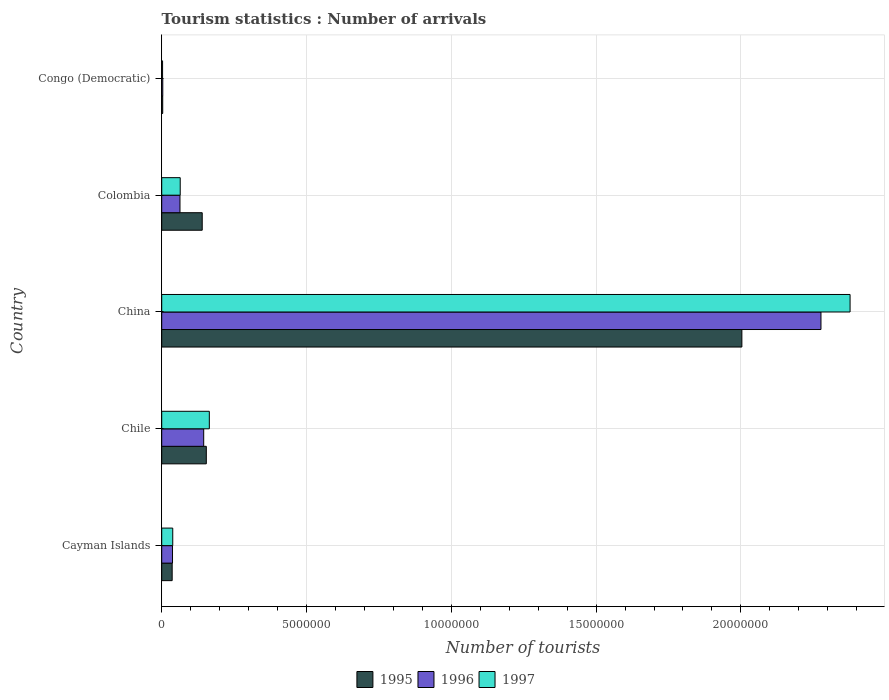How many different coloured bars are there?
Keep it short and to the point. 3. How many groups of bars are there?
Your response must be concise. 5. Are the number of bars per tick equal to the number of legend labels?
Ensure brevity in your answer.  Yes. Are the number of bars on each tick of the Y-axis equal?
Offer a terse response. Yes. How many bars are there on the 1st tick from the bottom?
Offer a terse response. 3. What is the label of the 1st group of bars from the top?
Your response must be concise. Congo (Democratic). In how many cases, is the number of bars for a given country not equal to the number of legend labels?
Keep it short and to the point. 0. What is the number of tourist arrivals in 1997 in Colombia?
Your answer should be very brief. 6.39e+05. Across all countries, what is the maximum number of tourist arrivals in 1997?
Your answer should be very brief. 2.38e+07. Across all countries, what is the minimum number of tourist arrivals in 1997?
Provide a short and direct response. 3.00e+04. In which country was the number of tourist arrivals in 1996 minimum?
Provide a short and direct response. Congo (Democratic). What is the total number of tourist arrivals in 1996 in the graph?
Offer a terse response. 2.53e+07. What is the difference between the number of tourist arrivals in 1996 in Chile and that in China?
Provide a succinct answer. -2.13e+07. What is the difference between the number of tourist arrivals in 1997 in Chile and the number of tourist arrivals in 1996 in Congo (Democratic)?
Your response must be concise. 1.61e+06. What is the average number of tourist arrivals in 1997 per country?
Offer a terse response. 5.29e+06. What is the difference between the number of tourist arrivals in 1996 and number of tourist arrivals in 1995 in China?
Offer a very short reply. 2.73e+06. What is the ratio of the number of tourist arrivals in 1996 in Chile to that in Colombia?
Offer a very short reply. 2.3. Is the number of tourist arrivals in 1997 in Cayman Islands less than that in China?
Provide a succinct answer. Yes. Is the difference between the number of tourist arrivals in 1996 in Chile and Congo (Democratic) greater than the difference between the number of tourist arrivals in 1995 in Chile and Congo (Democratic)?
Ensure brevity in your answer.  No. What is the difference between the highest and the second highest number of tourist arrivals in 1996?
Your response must be concise. 2.13e+07. What is the difference between the highest and the lowest number of tourist arrivals in 1995?
Keep it short and to the point. 2.00e+07. In how many countries, is the number of tourist arrivals in 1996 greater than the average number of tourist arrivals in 1996 taken over all countries?
Provide a short and direct response. 1. What does the 1st bar from the top in Colombia represents?
Give a very brief answer. 1997. What does the 2nd bar from the bottom in Colombia represents?
Keep it short and to the point. 1996. Is it the case that in every country, the sum of the number of tourist arrivals in 1995 and number of tourist arrivals in 1997 is greater than the number of tourist arrivals in 1996?
Keep it short and to the point. Yes. What is the difference between two consecutive major ticks on the X-axis?
Provide a succinct answer. 5.00e+06. Are the values on the major ticks of X-axis written in scientific E-notation?
Make the answer very short. No. How many legend labels are there?
Offer a terse response. 3. What is the title of the graph?
Provide a short and direct response. Tourism statistics : Number of arrivals. Does "1971" appear as one of the legend labels in the graph?
Make the answer very short. No. What is the label or title of the X-axis?
Make the answer very short. Number of tourists. What is the label or title of the Y-axis?
Your answer should be compact. Country. What is the Number of tourists of 1995 in Cayman Islands?
Offer a terse response. 3.61e+05. What is the Number of tourists in 1996 in Cayman Islands?
Ensure brevity in your answer.  3.73e+05. What is the Number of tourists in 1997 in Cayman Islands?
Your answer should be very brief. 3.81e+05. What is the Number of tourists in 1995 in Chile?
Your answer should be compact. 1.54e+06. What is the Number of tourists in 1996 in Chile?
Offer a very short reply. 1.45e+06. What is the Number of tourists in 1997 in Chile?
Your answer should be very brief. 1.64e+06. What is the Number of tourists of 1995 in China?
Make the answer very short. 2.00e+07. What is the Number of tourists in 1996 in China?
Your response must be concise. 2.28e+07. What is the Number of tourists of 1997 in China?
Offer a very short reply. 2.38e+07. What is the Number of tourists of 1995 in Colombia?
Your answer should be compact. 1.40e+06. What is the Number of tourists in 1996 in Colombia?
Keep it short and to the point. 6.31e+05. What is the Number of tourists in 1997 in Colombia?
Keep it short and to the point. 6.39e+05. What is the Number of tourists of 1995 in Congo (Democratic)?
Give a very brief answer. 3.50e+04. What is the Number of tourists in 1996 in Congo (Democratic)?
Provide a succinct answer. 3.70e+04. Across all countries, what is the maximum Number of tourists in 1995?
Offer a terse response. 2.00e+07. Across all countries, what is the maximum Number of tourists in 1996?
Offer a very short reply. 2.28e+07. Across all countries, what is the maximum Number of tourists of 1997?
Offer a terse response. 2.38e+07. Across all countries, what is the minimum Number of tourists of 1995?
Your answer should be very brief. 3.50e+04. Across all countries, what is the minimum Number of tourists in 1996?
Offer a terse response. 3.70e+04. Across all countries, what is the minimum Number of tourists in 1997?
Keep it short and to the point. 3.00e+04. What is the total Number of tourists of 1995 in the graph?
Your answer should be very brief. 2.34e+07. What is the total Number of tourists of 1996 in the graph?
Give a very brief answer. 2.53e+07. What is the total Number of tourists of 1997 in the graph?
Make the answer very short. 2.65e+07. What is the difference between the Number of tourists in 1995 in Cayman Islands and that in Chile?
Keep it short and to the point. -1.18e+06. What is the difference between the Number of tourists of 1996 in Cayman Islands and that in Chile?
Your response must be concise. -1.08e+06. What is the difference between the Number of tourists in 1997 in Cayman Islands and that in Chile?
Your answer should be compact. -1.26e+06. What is the difference between the Number of tourists of 1995 in Cayman Islands and that in China?
Provide a short and direct response. -1.97e+07. What is the difference between the Number of tourists of 1996 in Cayman Islands and that in China?
Provide a succinct answer. -2.24e+07. What is the difference between the Number of tourists of 1997 in Cayman Islands and that in China?
Ensure brevity in your answer.  -2.34e+07. What is the difference between the Number of tourists in 1995 in Cayman Islands and that in Colombia?
Offer a terse response. -1.04e+06. What is the difference between the Number of tourists of 1996 in Cayman Islands and that in Colombia?
Offer a very short reply. -2.58e+05. What is the difference between the Number of tourists in 1997 in Cayman Islands and that in Colombia?
Offer a very short reply. -2.58e+05. What is the difference between the Number of tourists of 1995 in Cayman Islands and that in Congo (Democratic)?
Your response must be concise. 3.26e+05. What is the difference between the Number of tourists in 1996 in Cayman Islands and that in Congo (Democratic)?
Your response must be concise. 3.36e+05. What is the difference between the Number of tourists in 1997 in Cayman Islands and that in Congo (Democratic)?
Your answer should be compact. 3.51e+05. What is the difference between the Number of tourists of 1995 in Chile and that in China?
Ensure brevity in your answer.  -1.85e+07. What is the difference between the Number of tourists of 1996 in Chile and that in China?
Keep it short and to the point. -2.13e+07. What is the difference between the Number of tourists of 1997 in Chile and that in China?
Provide a succinct answer. -2.21e+07. What is the difference between the Number of tourists of 1995 in Chile and that in Colombia?
Ensure brevity in your answer.  1.41e+05. What is the difference between the Number of tourists of 1996 in Chile and that in Colombia?
Provide a short and direct response. 8.19e+05. What is the difference between the Number of tourists in 1997 in Chile and that in Colombia?
Your response must be concise. 1.00e+06. What is the difference between the Number of tourists in 1995 in Chile and that in Congo (Democratic)?
Provide a short and direct response. 1.50e+06. What is the difference between the Number of tourists in 1996 in Chile and that in Congo (Democratic)?
Make the answer very short. 1.41e+06. What is the difference between the Number of tourists of 1997 in Chile and that in Congo (Democratic)?
Your answer should be very brief. 1.61e+06. What is the difference between the Number of tourists of 1995 in China and that in Colombia?
Give a very brief answer. 1.86e+07. What is the difference between the Number of tourists in 1996 in China and that in Colombia?
Give a very brief answer. 2.21e+07. What is the difference between the Number of tourists in 1997 in China and that in Colombia?
Give a very brief answer. 2.31e+07. What is the difference between the Number of tourists in 1995 in China and that in Congo (Democratic)?
Your answer should be very brief. 2.00e+07. What is the difference between the Number of tourists in 1996 in China and that in Congo (Democratic)?
Keep it short and to the point. 2.27e+07. What is the difference between the Number of tourists of 1997 in China and that in Congo (Democratic)?
Your answer should be compact. 2.37e+07. What is the difference between the Number of tourists of 1995 in Colombia and that in Congo (Democratic)?
Provide a succinct answer. 1.36e+06. What is the difference between the Number of tourists in 1996 in Colombia and that in Congo (Democratic)?
Offer a very short reply. 5.94e+05. What is the difference between the Number of tourists in 1997 in Colombia and that in Congo (Democratic)?
Your answer should be very brief. 6.09e+05. What is the difference between the Number of tourists in 1995 in Cayman Islands and the Number of tourists in 1996 in Chile?
Make the answer very short. -1.09e+06. What is the difference between the Number of tourists in 1995 in Cayman Islands and the Number of tourists in 1997 in Chile?
Offer a terse response. -1.28e+06. What is the difference between the Number of tourists of 1996 in Cayman Islands and the Number of tourists of 1997 in Chile?
Your answer should be compact. -1.27e+06. What is the difference between the Number of tourists of 1995 in Cayman Islands and the Number of tourists of 1996 in China?
Ensure brevity in your answer.  -2.24e+07. What is the difference between the Number of tourists in 1995 in Cayman Islands and the Number of tourists in 1997 in China?
Offer a very short reply. -2.34e+07. What is the difference between the Number of tourists in 1996 in Cayman Islands and the Number of tourists in 1997 in China?
Keep it short and to the point. -2.34e+07. What is the difference between the Number of tourists of 1995 in Cayman Islands and the Number of tourists of 1996 in Colombia?
Offer a very short reply. -2.70e+05. What is the difference between the Number of tourists in 1995 in Cayman Islands and the Number of tourists in 1997 in Colombia?
Keep it short and to the point. -2.78e+05. What is the difference between the Number of tourists in 1996 in Cayman Islands and the Number of tourists in 1997 in Colombia?
Ensure brevity in your answer.  -2.66e+05. What is the difference between the Number of tourists in 1995 in Cayman Islands and the Number of tourists in 1996 in Congo (Democratic)?
Make the answer very short. 3.24e+05. What is the difference between the Number of tourists of 1995 in Cayman Islands and the Number of tourists of 1997 in Congo (Democratic)?
Offer a terse response. 3.31e+05. What is the difference between the Number of tourists of 1996 in Cayman Islands and the Number of tourists of 1997 in Congo (Democratic)?
Keep it short and to the point. 3.43e+05. What is the difference between the Number of tourists of 1995 in Chile and the Number of tourists of 1996 in China?
Give a very brief answer. -2.12e+07. What is the difference between the Number of tourists of 1995 in Chile and the Number of tourists of 1997 in China?
Make the answer very short. -2.22e+07. What is the difference between the Number of tourists of 1996 in Chile and the Number of tourists of 1997 in China?
Keep it short and to the point. -2.23e+07. What is the difference between the Number of tourists of 1995 in Chile and the Number of tourists of 1996 in Colombia?
Your answer should be very brief. 9.09e+05. What is the difference between the Number of tourists in 1995 in Chile and the Number of tourists in 1997 in Colombia?
Give a very brief answer. 9.01e+05. What is the difference between the Number of tourists in 1996 in Chile and the Number of tourists in 1997 in Colombia?
Keep it short and to the point. 8.11e+05. What is the difference between the Number of tourists in 1995 in Chile and the Number of tourists in 1996 in Congo (Democratic)?
Provide a short and direct response. 1.50e+06. What is the difference between the Number of tourists of 1995 in Chile and the Number of tourists of 1997 in Congo (Democratic)?
Offer a very short reply. 1.51e+06. What is the difference between the Number of tourists of 1996 in Chile and the Number of tourists of 1997 in Congo (Democratic)?
Keep it short and to the point. 1.42e+06. What is the difference between the Number of tourists of 1995 in China and the Number of tourists of 1996 in Colombia?
Your answer should be very brief. 1.94e+07. What is the difference between the Number of tourists of 1995 in China and the Number of tourists of 1997 in Colombia?
Give a very brief answer. 1.94e+07. What is the difference between the Number of tourists of 1996 in China and the Number of tourists of 1997 in Colombia?
Your answer should be very brief. 2.21e+07. What is the difference between the Number of tourists of 1995 in China and the Number of tourists of 1996 in Congo (Democratic)?
Your answer should be very brief. 2.00e+07. What is the difference between the Number of tourists of 1995 in China and the Number of tourists of 1997 in Congo (Democratic)?
Your answer should be very brief. 2.00e+07. What is the difference between the Number of tourists in 1996 in China and the Number of tourists in 1997 in Congo (Democratic)?
Your answer should be very brief. 2.27e+07. What is the difference between the Number of tourists in 1995 in Colombia and the Number of tourists in 1996 in Congo (Democratic)?
Offer a very short reply. 1.36e+06. What is the difference between the Number of tourists in 1995 in Colombia and the Number of tourists in 1997 in Congo (Democratic)?
Your answer should be very brief. 1.37e+06. What is the difference between the Number of tourists of 1996 in Colombia and the Number of tourists of 1997 in Congo (Democratic)?
Offer a terse response. 6.01e+05. What is the average Number of tourists of 1995 per country?
Provide a succinct answer. 4.67e+06. What is the average Number of tourists in 1996 per country?
Provide a short and direct response. 5.05e+06. What is the average Number of tourists in 1997 per country?
Your response must be concise. 5.29e+06. What is the difference between the Number of tourists in 1995 and Number of tourists in 1996 in Cayman Islands?
Make the answer very short. -1.20e+04. What is the difference between the Number of tourists of 1996 and Number of tourists of 1997 in Cayman Islands?
Offer a very short reply. -8000. What is the difference between the Number of tourists of 1995 and Number of tourists of 1996 in Chile?
Offer a very short reply. 9.00e+04. What is the difference between the Number of tourists of 1995 and Number of tourists of 1997 in Chile?
Make the answer very short. -1.04e+05. What is the difference between the Number of tourists of 1996 and Number of tourists of 1997 in Chile?
Your answer should be very brief. -1.94e+05. What is the difference between the Number of tourists in 1995 and Number of tourists in 1996 in China?
Your answer should be compact. -2.73e+06. What is the difference between the Number of tourists of 1995 and Number of tourists of 1997 in China?
Give a very brief answer. -3.74e+06. What is the difference between the Number of tourists in 1996 and Number of tourists in 1997 in China?
Offer a terse response. -1.00e+06. What is the difference between the Number of tourists in 1995 and Number of tourists in 1996 in Colombia?
Keep it short and to the point. 7.68e+05. What is the difference between the Number of tourists of 1995 and Number of tourists of 1997 in Colombia?
Offer a terse response. 7.60e+05. What is the difference between the Number of tourists of 1996 and Number of tourists of 1997 in Colombia?
Your response must be concise. -8000. What is the difference between the Number of tourists in 1995 and Number of tourists in 1996 in Congo (Democratic)?
Your answer should be very brief. -2000. What is the difference between the Number of tourists in 1995 and Number of tourists in 1997 in Congo (Democratic)?
Keep it short and to the point. 5000. What is the difference between the Number of tourists of 1996 and Number of tourists of 1997 in Congo (Democratic)?
Offer a terse response. 7000. What is the ratio of the Number of tourists of 1995 in Cayman Islands to that in Chile?
Provide a succinct answer. 0.23. What is the ratio of the Number of tourists of 1996 in Cayman Islands to that in Chile?
Give a very brief answer. 0.26. What is the ratio of the Number of tourists in 1997 in Cayman Islands to that in Chile?
Your answer should be compact. 0.23. What is the ratio of the Number of tourists in 1995 in Cayman Islands to that in China?
Keep it short and to the point. 0.02. What is the ratio of the Number of tourists in 1996 in Cayman Islands to that in China?
Give a very brief answer. 0.02. What is the ratio of the Number of tourists in 1997 in Cayman Islands to that in China?
Provide a short and direct response. 0.02. What is the ratio of the Number of tourists of 1995 in Cayman Islands to that in Colombia?
Your answer should be very brief. 0.26. What is the ratio of the Number of tourists of 1996 in Cayman Islands to that in Colombia?
Make the answer very short. 0.59. What is the ratio of the Number of tourists in 1997 in Cayman Islands to that in Colombia?
Provide a succinct answer. 0.6. What is the ratio of the Number of tourists of 1995 in Cayman Islands to that in Congo (Democratic)?
Provide a short and direct response. 10.31. What is the ratio of the Number of tourists in 1996 in Cayman Islands to that in Congo (Democratic)?
Ensure brevity in your answer.  10.08. What is the ratio of the Number of tourists in 1995 in Chile to that in China?
Offer a very short reply. 0.08. What is the ratio of the Number of tourists of 1996 in Chile to that in China?
Make the answer very short. 0.06. What is the ratio of the Number of tourists in 1997 in Chile to that in China?
Offer a terse response. 0.07. What is the ratio of the Number of tourists in 1995 in Chile to that in Colombia?
Offer a terse response. 1.1. What is the ratio of the Number of tourists in 1996 in Chile to that in Colombia?
Give a very brief answer. 2.3. What is the ratio of the Number of tourists in 1997 in Chile to that in Colombia?
Make the answer very short. 2.57. What is the ratio of the Number of tourists in 1995 in Chile to that in Congo (Democratic)?
Make the answer very short. 44. What is the ratio of the Number of tourists of 1996 in Chile to that in Congo (Democratic)?
Give a very brief answer. 39.19. What is the ratio of the Number of tourists in 1997 in Chile to that in Congo (Democratic)?
Offer a very short reply. 54.8. What is the ratio of the Number of tourists in 1995 in China to that in Colombia?
Make the answer very short. 14.32. What is the ratio of the Number of tourists in 1996 in China to that in Colombia?
Your answer should be very brief. 36.08. What is the ratio of the Number of tourists of 1997 in China to that in Colombia?
Offer a terse response. 37.2. What is the ratio of the Number of tourists in 1995 in China to that in Congo (Democratic)?
Keep it short and to the point. 572.4. What is the ratio of the Number of tourists in 1996 in China to that in Congo (Democratic)?
Offer a terse response. 615.27. What is the ratio of the Number of tourists of 1997 in China to that in Congo (Democratic)?
Make the answer very short. 792.33. What is the ratio of the Number of tourists of 1995 in Colombia to that in Congo (Democratic)?
Make the answer very short. 39.97. What is the ratio of the Number of tourists in 1996 in Colombia to that in Congo (Democratic)?
Offer a very short reply. 17.05. What is the ratio of the Number of tourists of 1997 in Colombia to that in Congo (Democratic)?
Offer a very short reply. 21.3. What is the difference between the highest and the second highest Number of tourists of 1995?
Ensure brevity in your answer.  1.85e+07. What is the difference between the highest and the second highest Number of tourists of 1996?
Ensure brevity in your answer.  2.13e+07. What is the difference between the highest and the second highest Number of tourists in 1997?
Your response must be concise. 2.21e+07. What is the difference between the highest and the lowest Number of tourists in 1995?
Offer a terse response. 2.00e+07. What is the difference between the highest and the lowest Number of tourists of 1996?
Your answer should be very brief. 2.27e+07. What is the difference between the highest and the lowest Number of tourists of 1997?
Ensure brevity in your answer.  2.37e+07. 